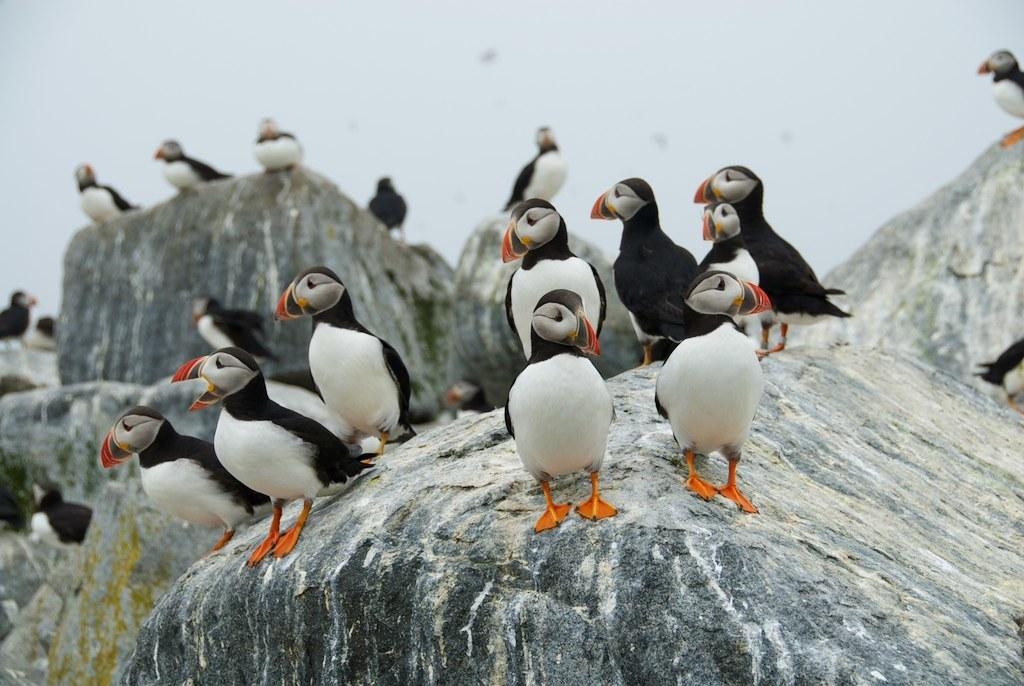What type of animal is in the image? There is a baby penguin in the image. What can be seen at the top of the image? The sky is visible at the top of the image. What flavor of waves can be seen in the image? There are no waves present in the image, and therefore no flavor can be associated with them. 